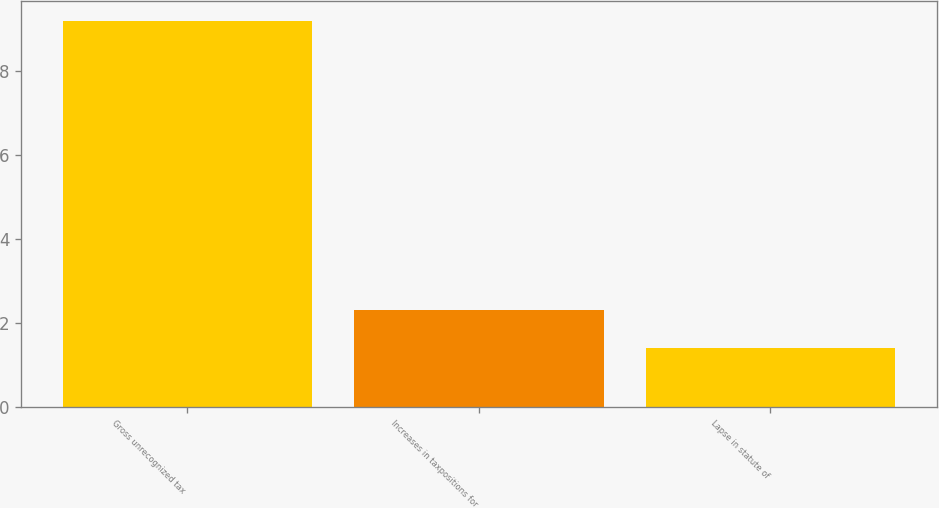<chart> <loc_0><loc_0><loc_500><loc_500><bar_chart><fcel>Gross unrecognized tax<fcel>Increases in taxpositions for<fcel>Lapse in statute of<nl><fcel>9.2<fcel>2.3<fcel>1.4<nl></chart> 